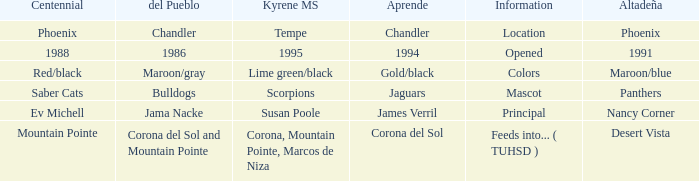Which Altadeña has a Aprende of jaguars? Panthers. 